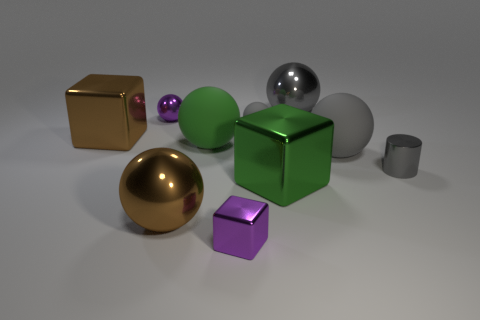Subtract all yellow cylinders. How many gray balls are left? 3 Subtract 2 balls. How many balls are left? 4 Subtract all brown balls. How many balls are left? 5 Subtract all tiny rubber balls. How many balls are left? 5 Subtract all cyan balls. Subtract all brown cubes. How many balls are left? 6 Subtract all cylinders. How many objects are left? 9 Subtract 0 green cylinders. How many objects are left? 10 Subtract all blue metallic things. Subtract all brown metallic blocks. How many objects are left? 9 Add 9 big gray matte objects. How many big gray matte objects are left? 10 Add 8 large green metal blocks. How many large green metal blocks exist? 9 